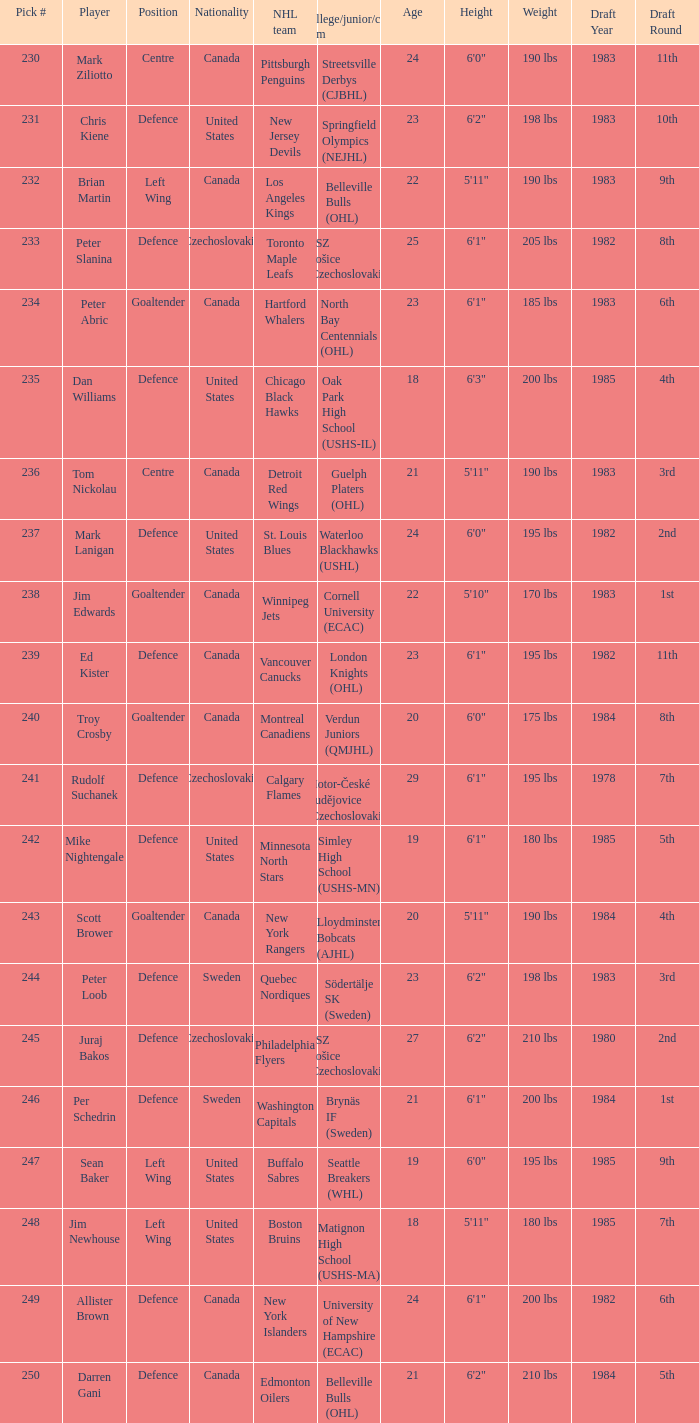To which organziation does the  winnipeg jets belong to? Cornell University (ECAC). 